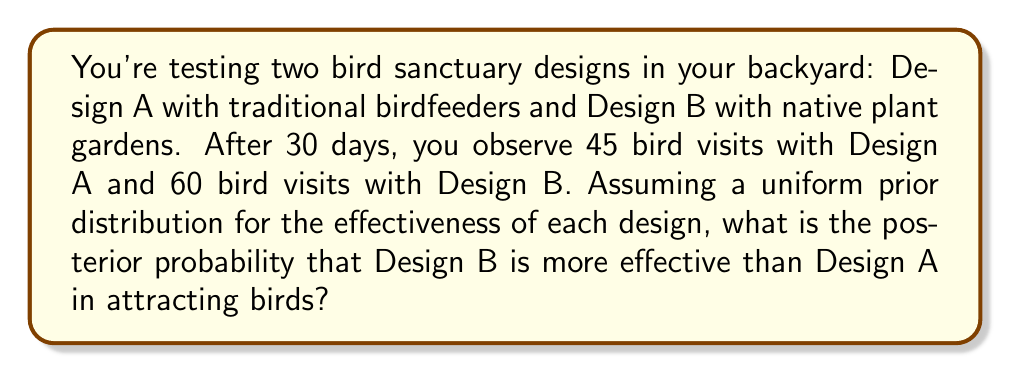Teach me how to tackle this problem. To solve this problem using Bayesian A/B testing, we'll follow these steps:

1) First, we need to define our prior beliefs. With a uniform prior, we assume that all effectiveness levels are equally likely for both designs before seeing the data.

2) We'll use a Beta distribution as our conjugate prior for the binomial likelihood of bird visits. The uniform prior is equivalent to a Beta(1,1) distribution.

3) After observing the data, our posterior distributions for the effectiveness of each design will be:

   Design A: Beta(46, 16)  [1 + 45 successes, 1 + 15 failures]
   Design B: Beta(61, 1)   [1 + 60 successes, 1 + 0 failures]

4) To find the probability that Design B is more effective, we need to calculate:

   $$P(θ_B > θ_A) = \int_0^1 \int_0^{θ_B} f_A(θ_A) f_B(θ_B) dθ_A dθ_B$$

   where $f_A$ and $f_B$ are the probability density functions of the Beta distributions for Designs A and B respectively.

5) This integral doesn't have a closed-form solution, so we'll use a Monte Carlo simulation to approximate it:

   a) Generate a large number of samples (e.g., 100,000) from each posterior distribution.
   b) Count the proportion of times the sample from Design B is greater than the sample from Design A.

6) Using Python with NumPy and SciPy libraries:

   ```python
   import numpy as np
   from scipy.stats import beta

   np.random.seed(0)  # for reproducibility
   n_samples = 100000

   samples_A = beta.rvs(46, 16, size=n_samples)
   samples_B = beta.rvs(61, 1, size=n_samples)

   prob_B_better = np.mean(samples_B > samples_A)
   ```

7) This simulation gives us a probability of approximately 0.9997, or 99.97%.
Answer: The posterior probability that Design B is more effective than Design A in attracting birds is approximately 0.9997 or 99.97%. 